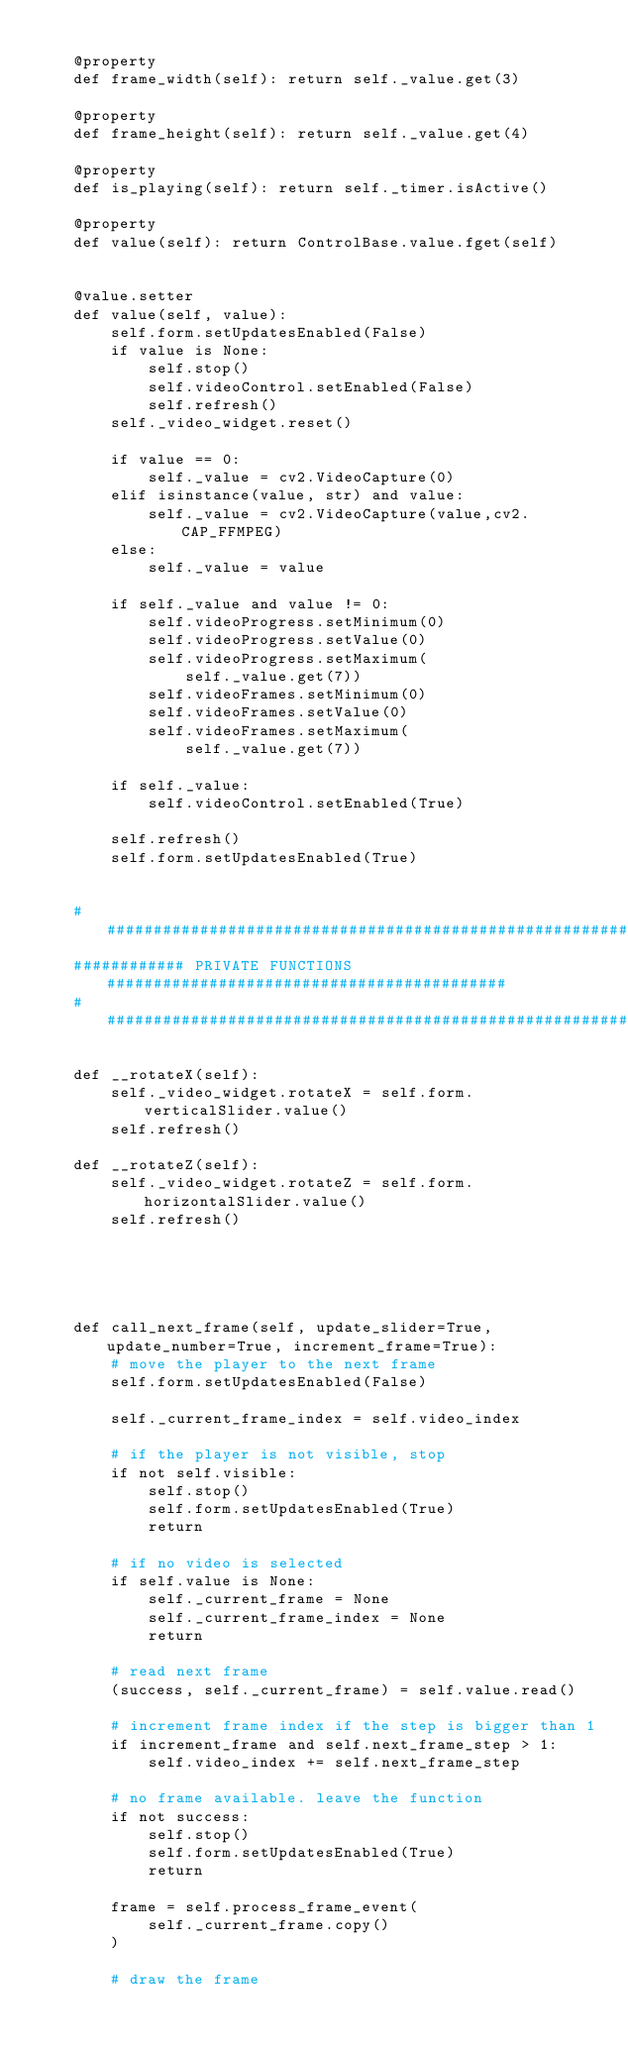Convert code to text. <code><loc_0><loc_0><loc_500><loc_500><_Python_>
    @property
    def frame_width(self): return self._value.get(3)

    @property
    def frame_height(self): return self._value.get(4)

    @property
    def is_playing(self): return self._timer.isActive()

    @property
    def value(self): return ControlBase.value.fget(self)


    @value.setter
    def value(self, value):
        self.form.setUpdatesEnabled(False)
        if value is None:
            self.stop()
            self.videoControl.setEnabled(False)
            self.refresh()
        self._video_widget.reset()

        if value == 0:
            self._value = cv2.VideoCapture(0)
        elif isinstance(value, str) and value:
            self._value = cv2.VideoCapture(value,cv2.CAP_FFMPEG)
        else:
            self._value = value

        if self._value and value != 0:
            self.videoProgress.setMinimum(0)
            self.videoProgress.setValue(0)
            self.videoProgress.setMaximum(
                self._value.get(7))
            self.videoFrames.setMinimum(0)
            self.videoFrames.setValue(0)
            self.videoFrames.setMaximum(
                self._value.get(7))

        if self._value:
            self.videoControl.setEnabled(True)

        self.refresh()
        self.form.setUpdatesEnabled(True)


    ##########################################################################
    ############ PRIVATE FUNCTIONS ###########################################
    ##########################################################################

    def __rotateX(self):
        self._video_widget.rotateX = self.form.verticalSlider.value()
        self.refresh()

    def __rotateZ(self):
        self._video_widget.rotateZ = self.form.horizontalSlider.value()
        self.refresh()





    def call_next_frame(self, update_slider=True, update_number=True, increment_frame=True):
        # move the player to the next frame
        self.form.setUpdatesEnabled(False)

        self._current_frame_index = self.video_index

        # if the player is not visible, stop
        if not self.visible:
            self.stop()
            self.form.setUpdatesEnabled(True)
            return

        # if no video is selected
        if self.value is None:
            self._current_frame = None
            self._current_frame_index = None
            return

        # read next frame
        (success, self._current_frame) = self.value.read()

        # increment frame index if the step is bigger than 1
        if increment_frame and self.next_frame_step > 1:
            self.video_index += self.next_frame_step

        # no frame available. leave the function
        if not success:
            self.stop()
            self.form.setUpdatesEnabled(True)
            return

        frame = self.process_frame_event(
            self._current_frame.copy()
        )

        # draw the frame</code> 